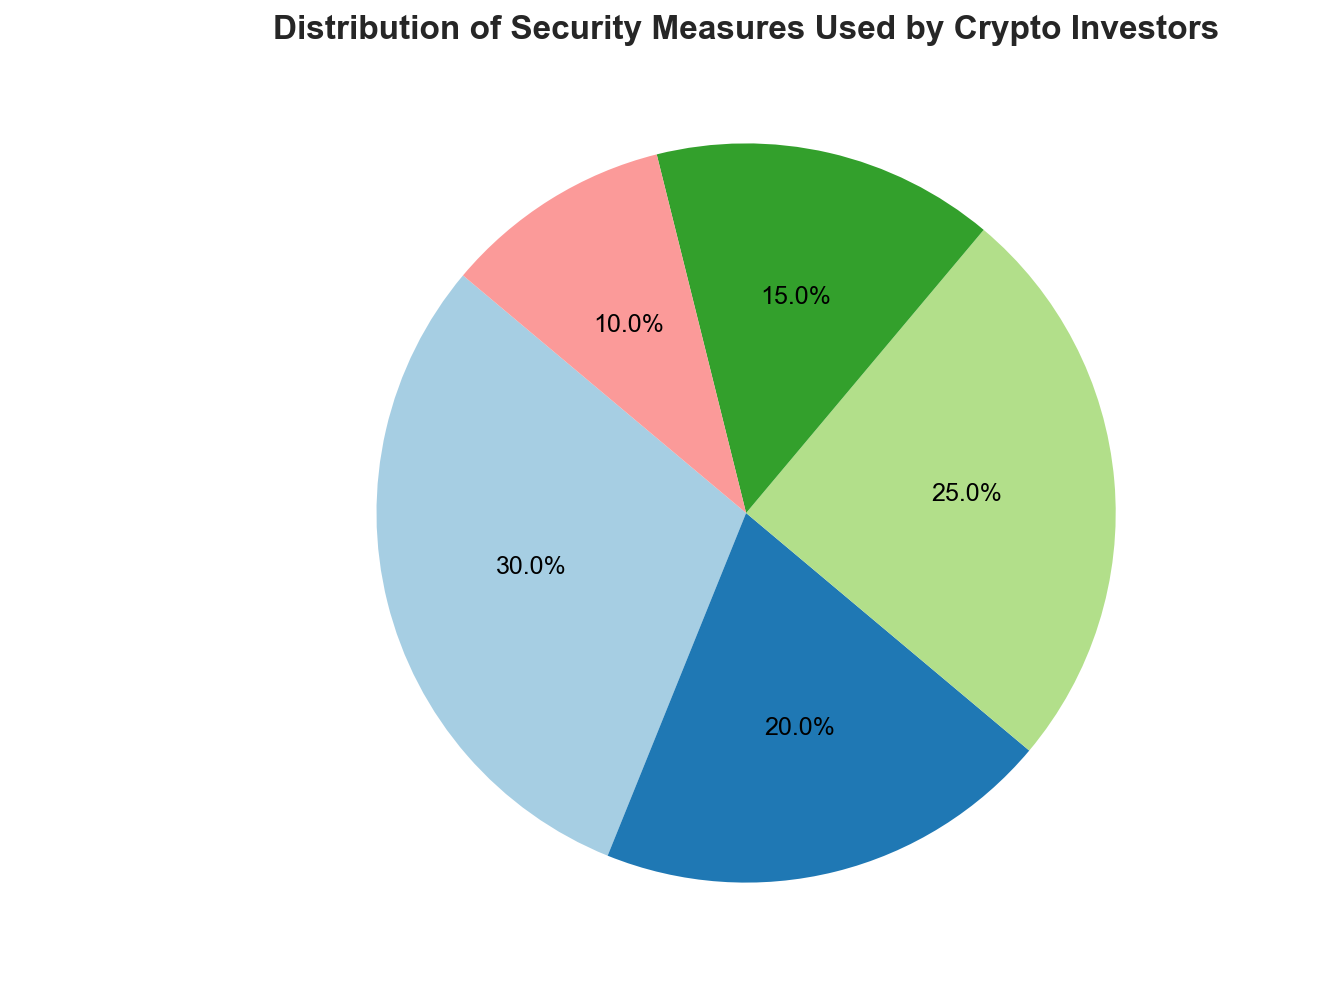What's the combined percentage of investors using Cold Storage and Hardware Wallets? To find the combined percentage, add the percentage of Cold Storage (25%) and the percentage of Hardware Wallets (10%). This yields 25% + 10% = 35%.
Answer: 35% Which security measure is used by the fewest investors? Review the percentages for each security measure. Hardware Wallets have the smallest percentage at 10%.
Answer: Hardware Wallets What is the difference in the percentage of investors using Two-Factor Authentication compared to Multi-Signature? Subtract the percentage of Multi-Signature (20%) from the percentage of Two-Factor Authentication (30%). This results in 30% - 20% = 10%.
Answer: 10% Which two security measures combined are used by more than 40% of investors? Check pairs of percentages to see which combinations exceed 40%. Two-Factor Authentication (30%) and Cold Storage (25%) total 30% + 25% = 55%, which exceeds 40%.
Answer: Two-Factor Authentication and Cold Storage Rank the security measures from most to least used. Order the percentages from highest to lowest: Two-Factor Authentication (30%), Cold Storage (25%), Multi-Signature (20%), Biometric Security (15%), Hardware Wallets (10%).
Answer: Two-Factor Authentication, Cold Storage, Multi-Signature, Biometric Security, Hardware Wallets What is the median percentage of all security measures used? Organize the percentages in ascending order: 10%, 15%, 20%, 25%, 30%. The median is the middle value, which is 20%.
Answer: 20% How many security measures account for more than 20% each? Review each security measure and count those with a percentage higher than 20%. Two-Factor Authentication (30%) and Cold Storage (25%) both exceed 20%.
Answer: 2 If the total sum of all percentages is 100%, what is the combined percentage of measures not involving physical devices (Two-Factor Authentication, Biometric Security, Multi-Signature)? Add the percentages for Two-Factor Authentication (30%), Biometric Security (15%), and Multi-Signature (20%). This adds up to 30% + 15% + 20% = 65%.
Answer: 65% What percentage more investors use Two-Factor Authentication compared to Biometric Security? Subtract Biometric Security's percentage (15%) from Two-Factor Authentication's percentage (30%). This results in 30% - 15% = 15%.
Answer: 15% What color represents Cold Storage in the pie chart? Examine the pie chart to determine the color used for the section labeled "Cold Storage". Since the actual pie chart is not visible, this question cannot be definitively answered without viewing the chart.
Answer: Unknown (needs visual confirmation) 